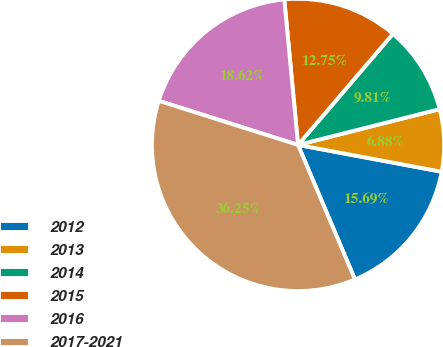Convert chart. <chart><loc_0><loc_0><loc_500><loc_500><pie_chart><fcel>2012<fcel>2013<fcel>2014<fcel>2015<fcel>2016<fcel>2017-2021<nl><fcel>15.69%<fcel>6.88%<fcel>9.81%<fcel>12.75%<fcel>18.62%<fcel>36.25%<nl></chart> 